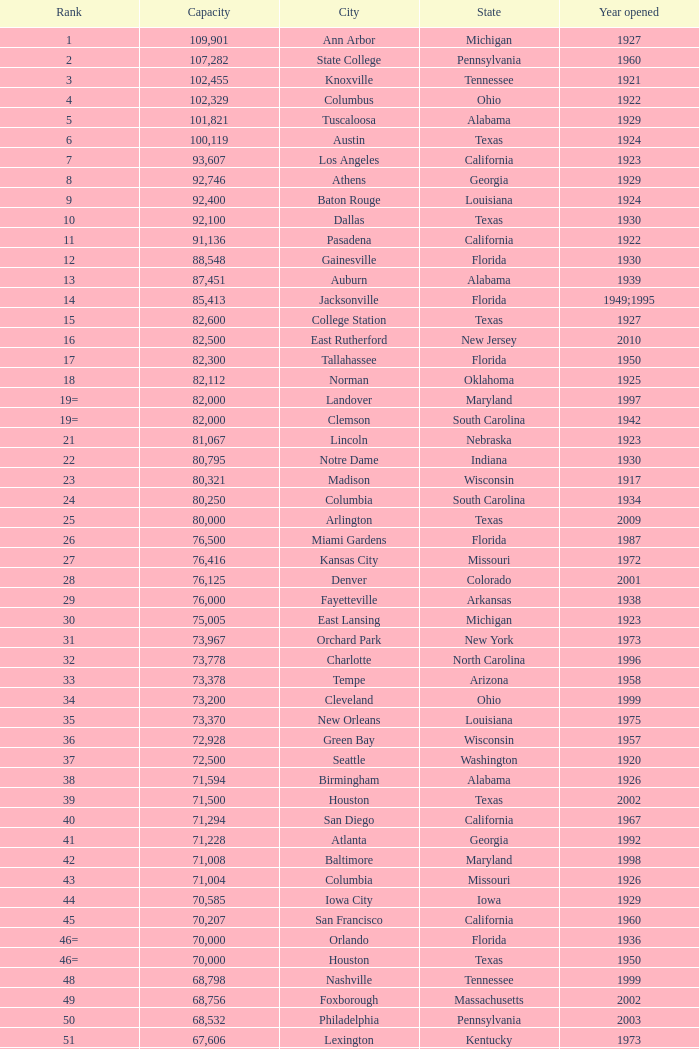What was the ranking for the year 1959 when it opened in pennsylvania? 134=. 